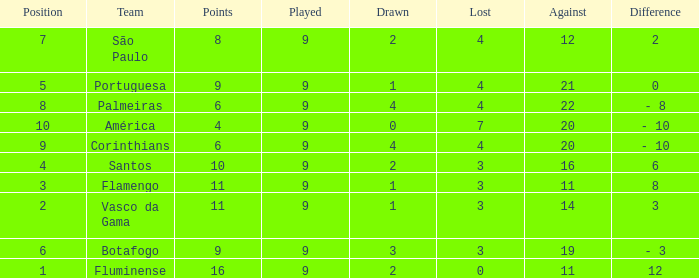Which against has the greatest value with a difference of 12? 11.0. 